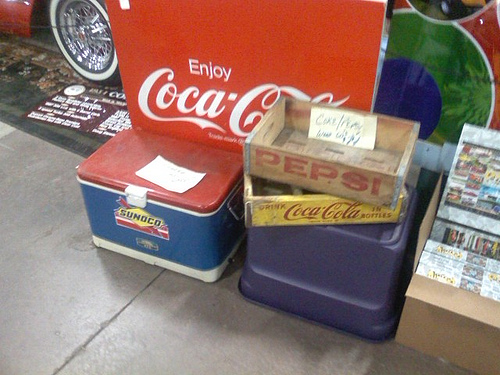<image>
Is the note on the cooler? Yes. Looking at the image, I can see the note is positioned on top of the cooler, with the cooler providing support. Is there a tire on the sign? No. The tire is not positioned on the sign. They may be near each other, but the tire is not supported by or resting on top of the sign. 